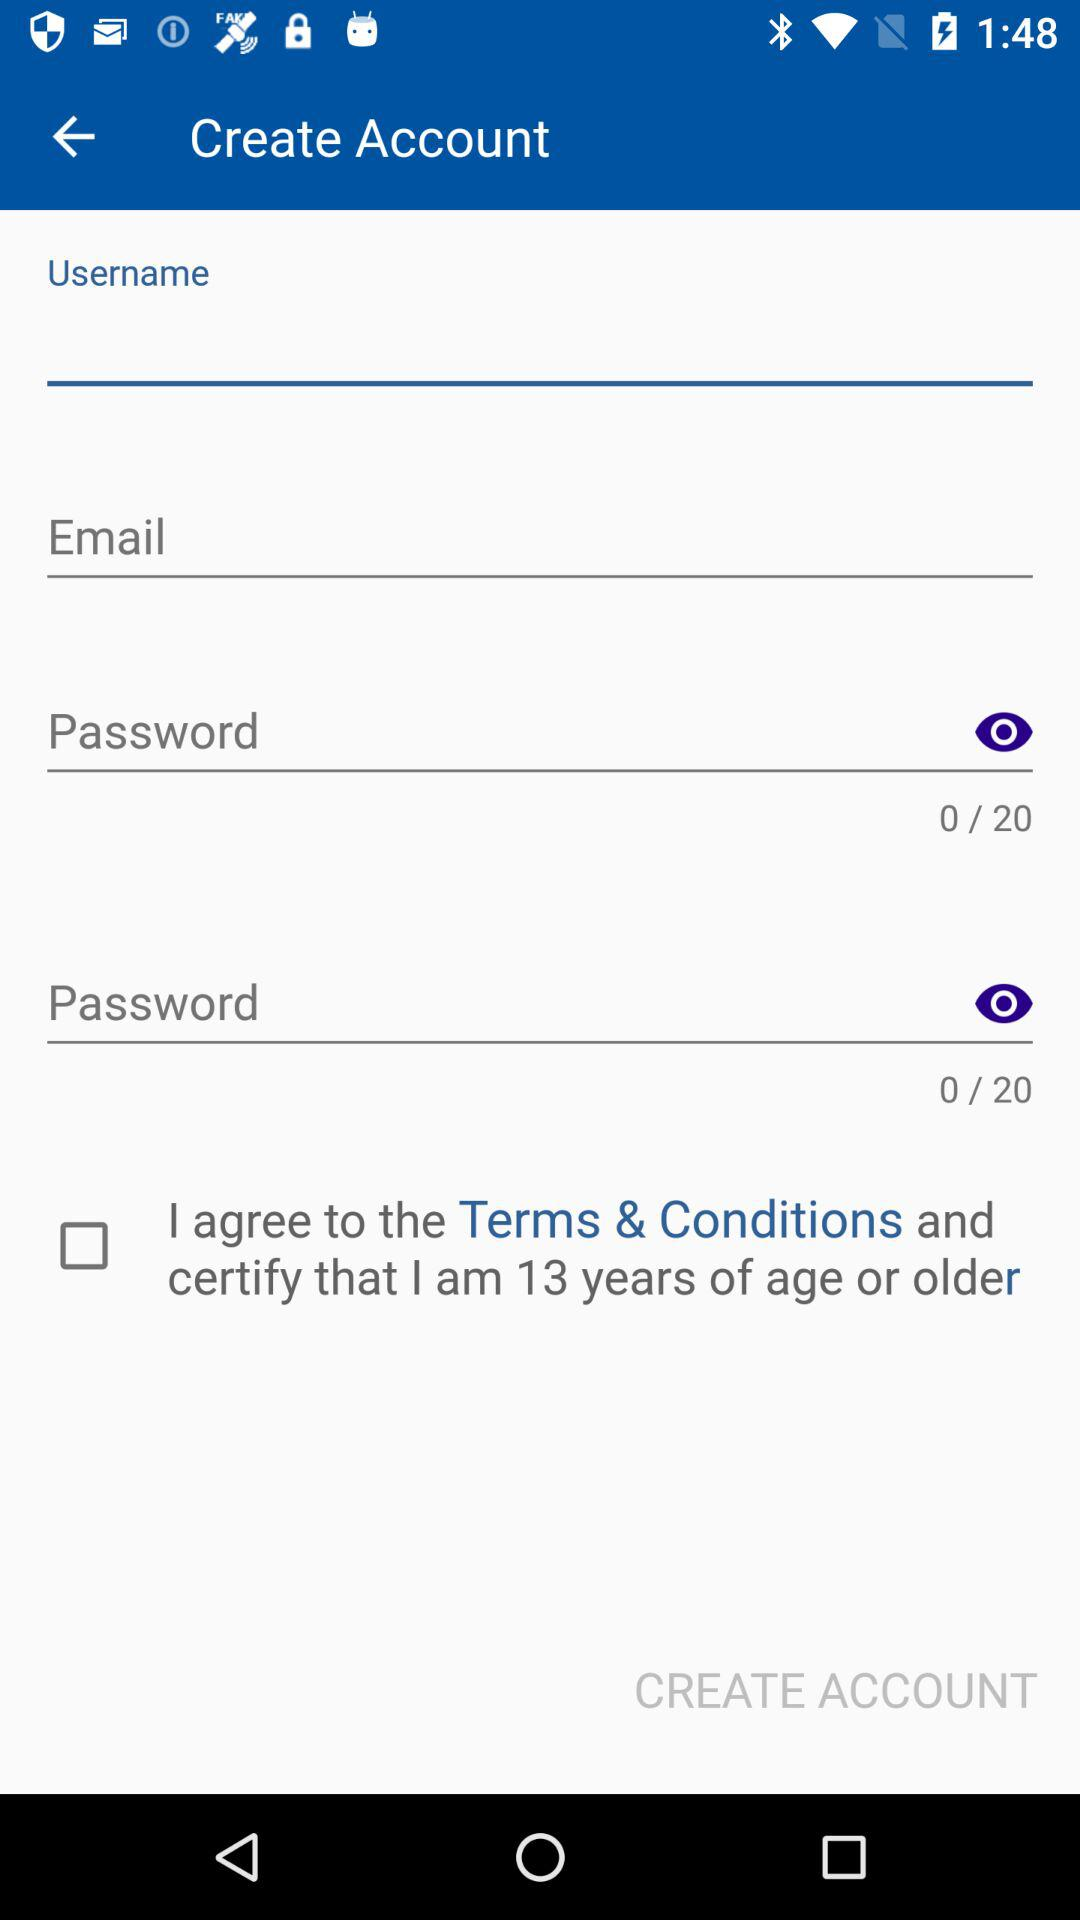How many characters should the password be?
When the provided information is insufficient, respond with <no answer>. <no answer> 